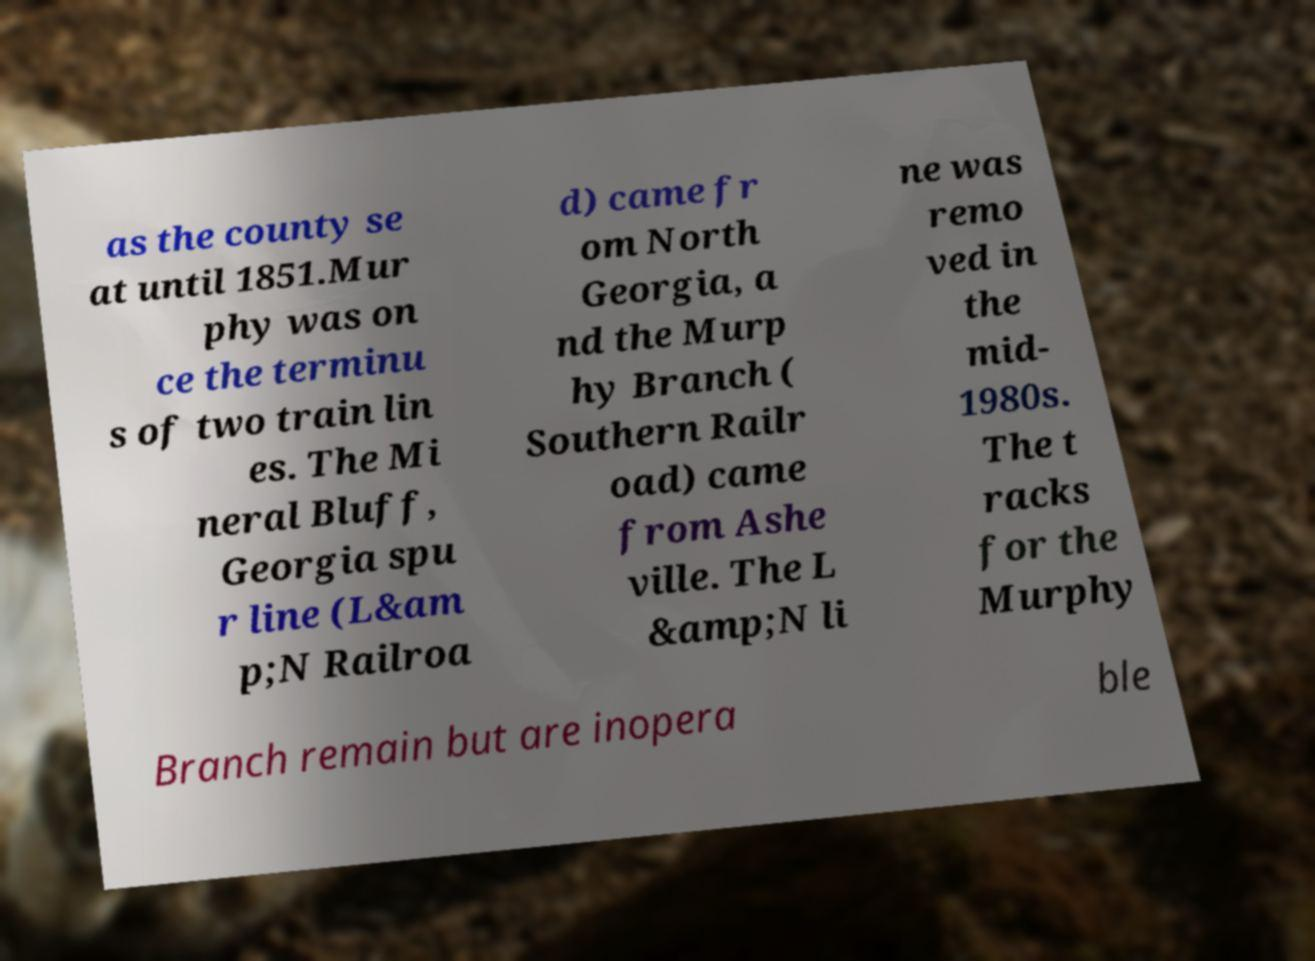There's text embedded in this image that I need extracted. Can you transcribe it verbatim? as the county se at until 1851.Mur phy was on ce the terminu s of two train lin es. The Mi neral Bluff, Georgia spu r line (L&am p;N Railroa d) came fr om North Georgia, a nd the Murp hy Branch ( Southern Railr oad) came from Ashe ville. The L &amp;N li ne was remo ved in the mid- 1980s. The t racks for the Murphy Branch remain but are inopera ble 